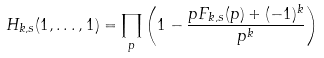Convert formula to latex. <formula><loc_0><loc_0><loc_500><loc_500>H _ { k , s } ( 1 , \dots , 1 ) = \prod _ { p } \left ( 1 - \frac { p F _ { k , s } ( p ) + ( - 1 ) ^ { k } } { p ^ { k } } \right )</formula> 